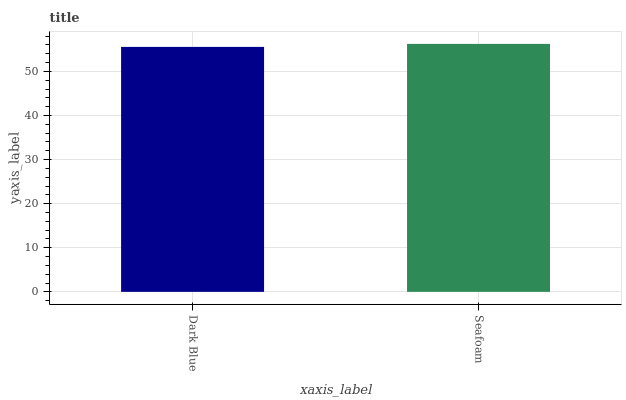Is Dark Blue the minimum?
Answer yes or no. Yes. Is Seafoam the maximum?
Answer yes or no. Yes. Is Seafoam the minimum?
Answer yes or no. No. Is Seafoam greater than Dark Blue?
Answer yes or no. Yes. Is Dark Blue less than Seafoam?
Answer yes or no. Yes. Is Dark Blue greater than Seafoam?
Answer yes or no. No. Is Seafoam less than Dark Blue?
Answer yes or no. No. Is Seafoam the high median?
Answer yes or no. Yes. Is Dark Blue the low median?
Answer yes or no. Yes. Is Dark Blue the high median?
Answer yes or no. No. Is Seafoam the low median?
Answer yes or no. No. 